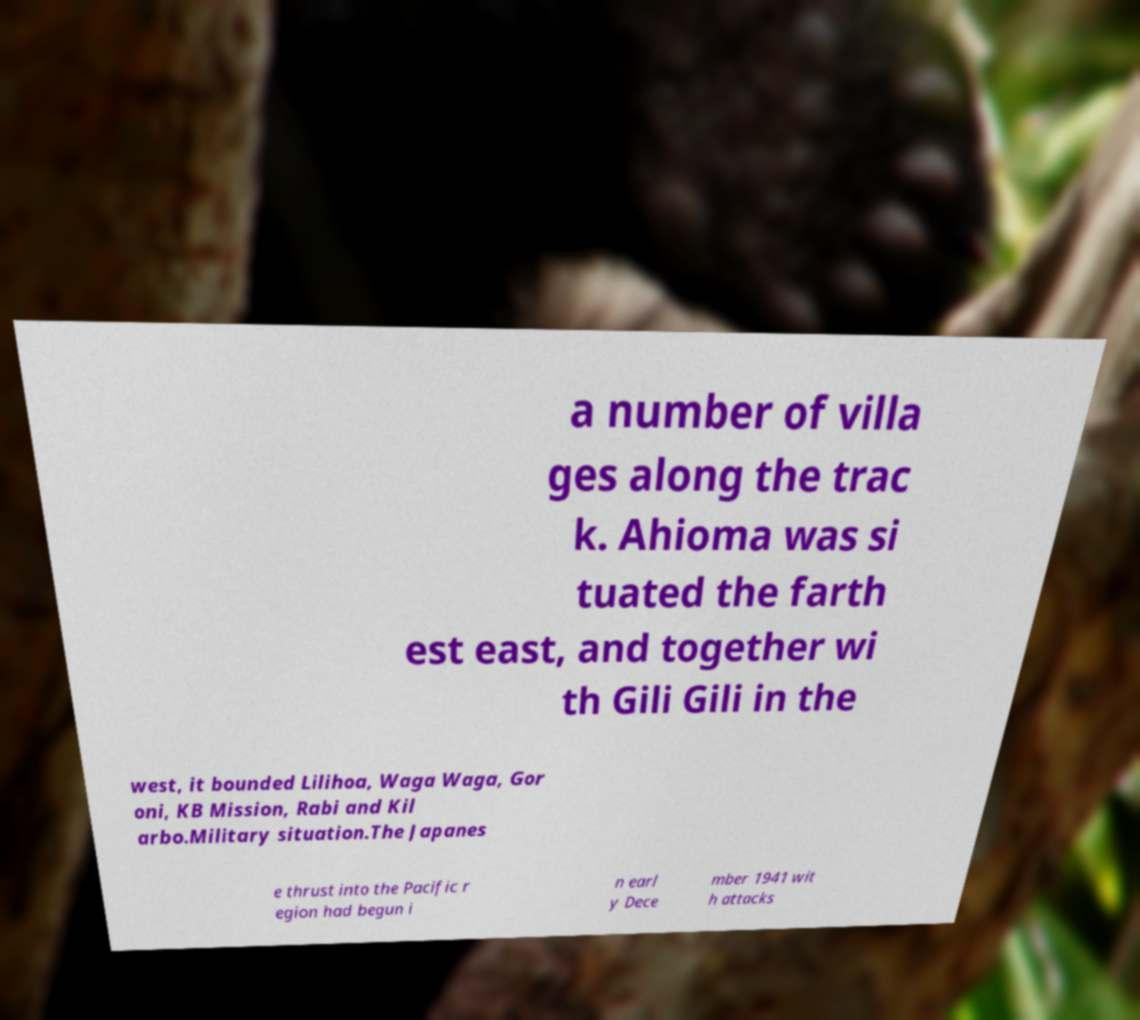Can you accurately transcribe the text from the provided image for me? a number of villa ges along the trac k. Ahioma was si tuated the farth est east, and together wi th Gili Gili in the west, it bounded Lilihoa, Waga Waga, Gor oni, KB Mission, Rabi and Kil arbo.Military situation.The Japanes e thrust into the Pacific r egion had begun i n earl y Dece mber 1941 wit h attacks 